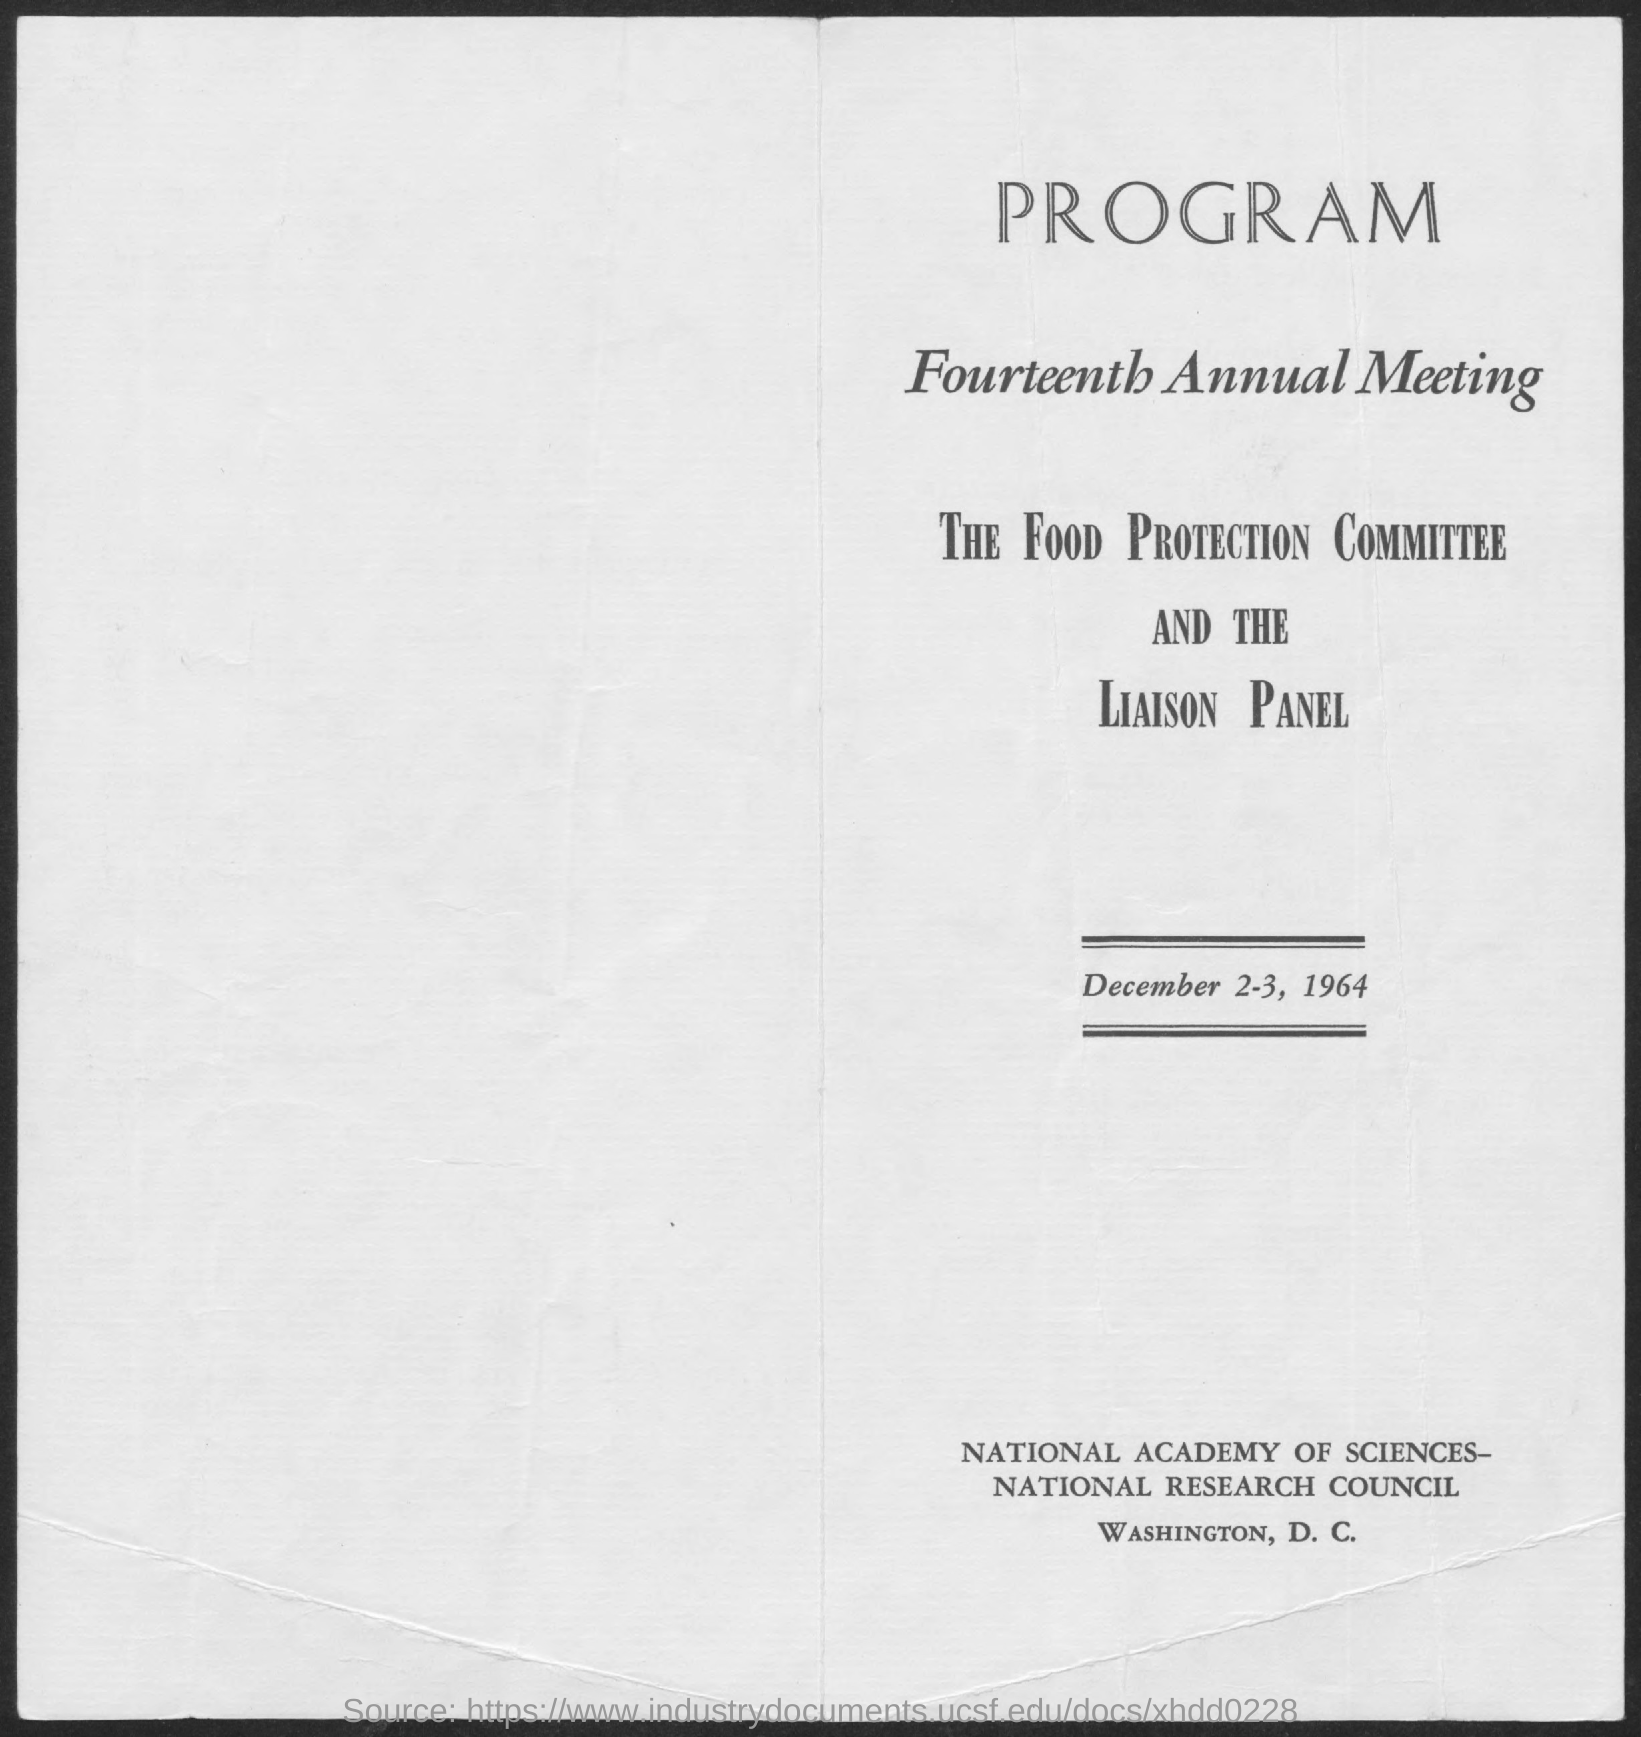Identify some key points in this picture. The date mentioned in the document is December 2-3, 1964. The second title in this document is "Fourteenth Annual Meeting.. 